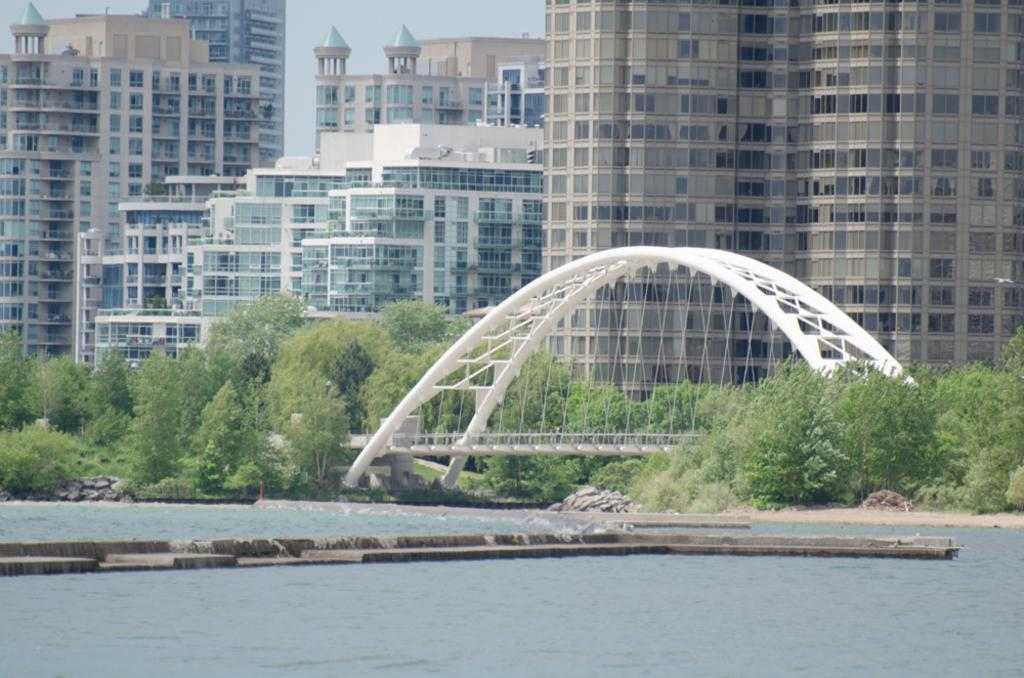What is one of the natural elements present in the image? There is water in the image. What type of geological feature can be seen in the image? There are rocks in the image. What type of vegetation is present in the image? There are trees in the image. What type of man-made structures are present in the image? There are buildings in the image. What type of infrastructure is present in the image? There is a bridge in the image. What is visible at the top of the image? The sky is visible at the top of the image. What type of holiday is being celebrated in the image? There is no indication of a holiday being celebrated in the image. Can you see anyone swimming in the water in the image? There are no people visible in the image, so it cannot be determined if anyone is swimming in the water. 